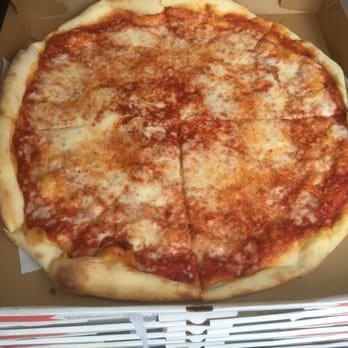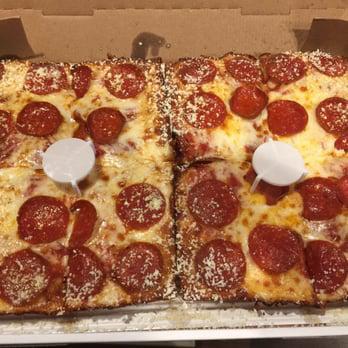The first image is the image on the left, the second image is the image on the right. Analyze the images presented: Is the assertion "No image shows a round pizza or triangular slice, and one image shows less than a complete rectangular pizza." valid? Answer yes or no. No. The first image is the image on the left, the second image is the image on the right. For the images displayed, is the sentence "The pizzas in both images are not circles, but are shaped like rectangles instead." factually correct? Answer yes or no. No. 